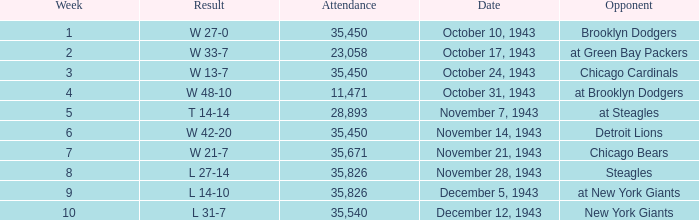How many attendances have w 48-10 as the result? 11471.0. 